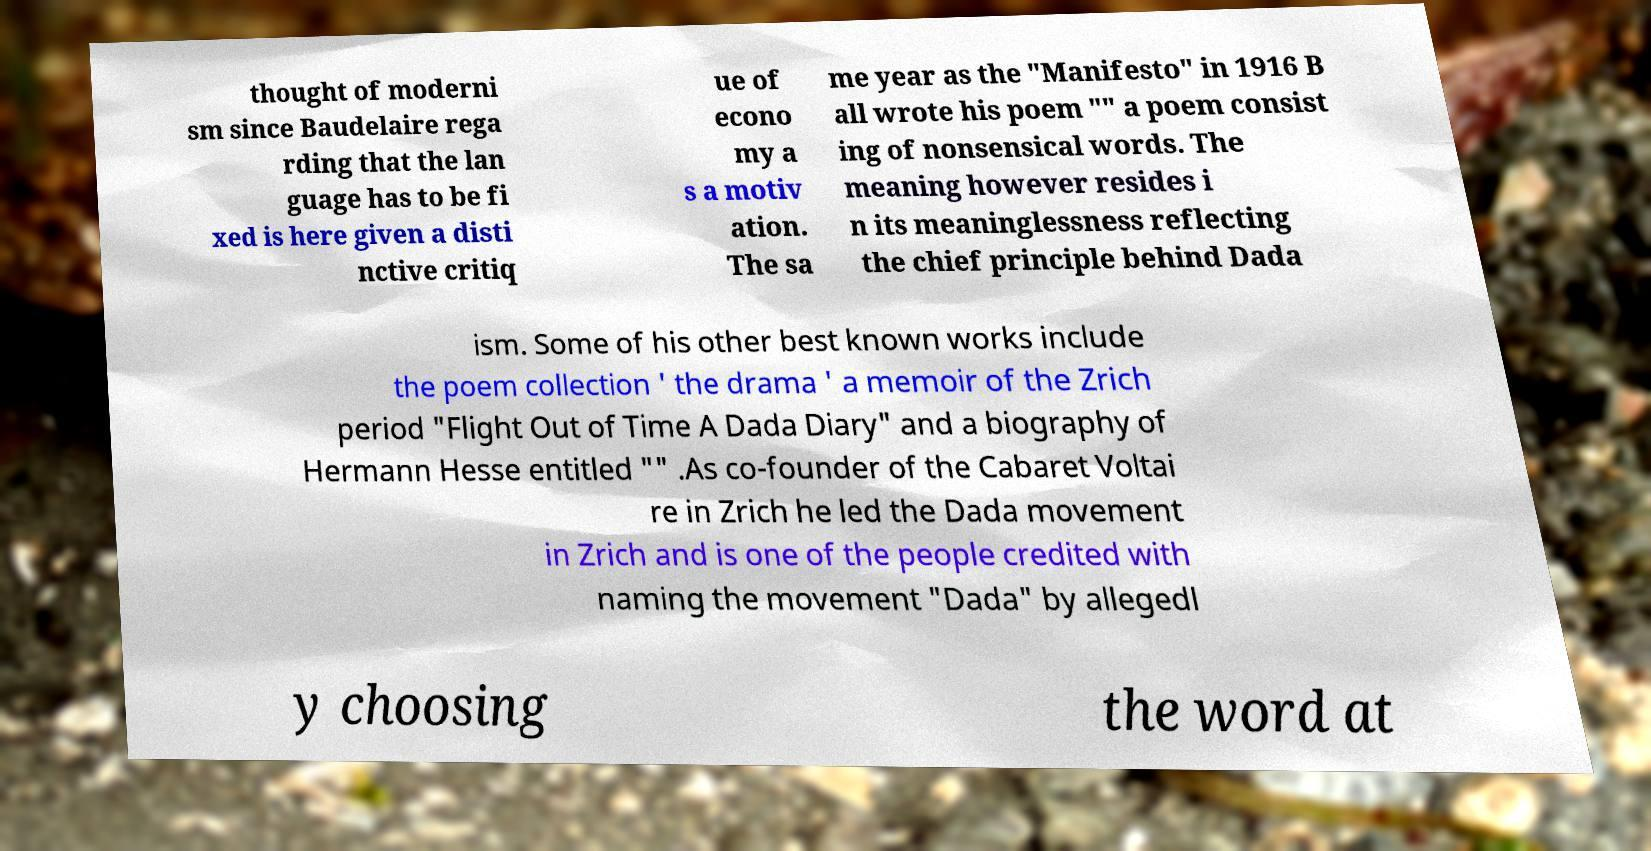For documentation purposes, I need the text within this image transcribed. Could you provide that? thought of moderni sm since Baudelaire rega rding that the lan guage has to be fi xed is here given a disti nctive critiq ue of econo my a s a motiv ation. The sa me year as the "Manifesto" in 1916 B all wrote his poem "" a poem consist ing of nonsensical words. The meaning however resides i n its meaninglessness reflecting the chief principle behind Dada ism. Some of his other best known works include the poem collection ' the drama ' a memoir of the Zrich period "Flight Out of Time A Dada Diary" and a biography of Hermann Hesse entitled "" .As co-founder of the Cabaret Voltai re in Zrich he led the Dada movement in Zrich and is one of the people credited with naming the movement "Dada" by allegedl y choosing the word at 